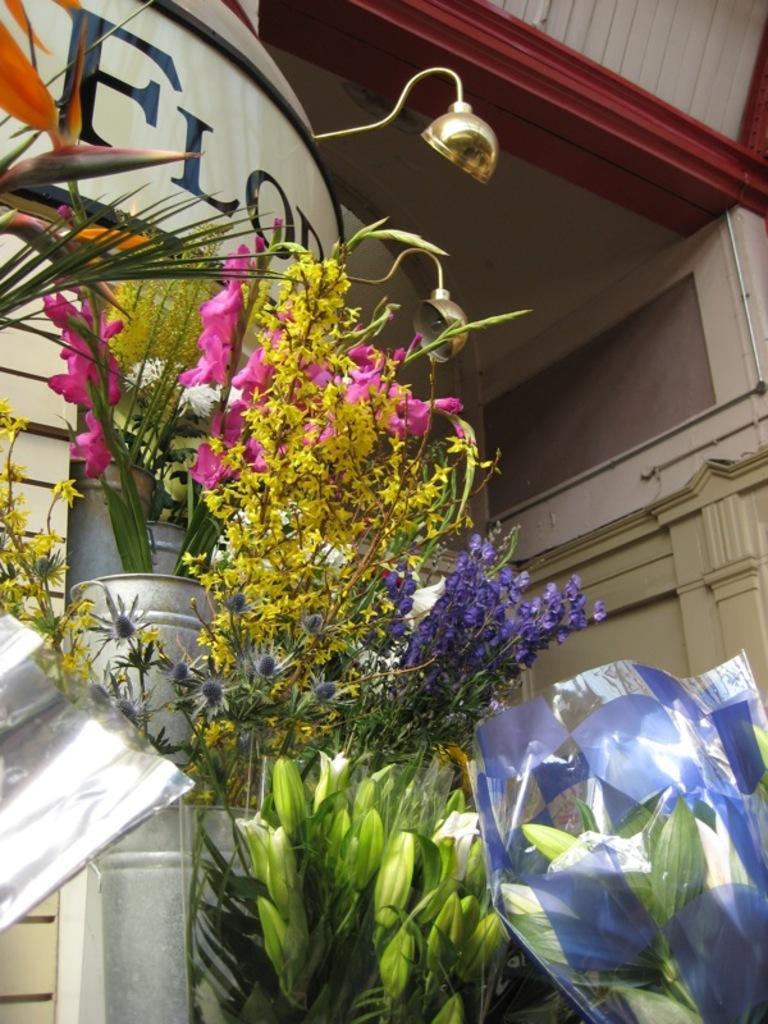Please provide a concise description of this image. In the foreground of the picture I can see the flower bouquets. It is looking like a lamp at the top of the picture. 